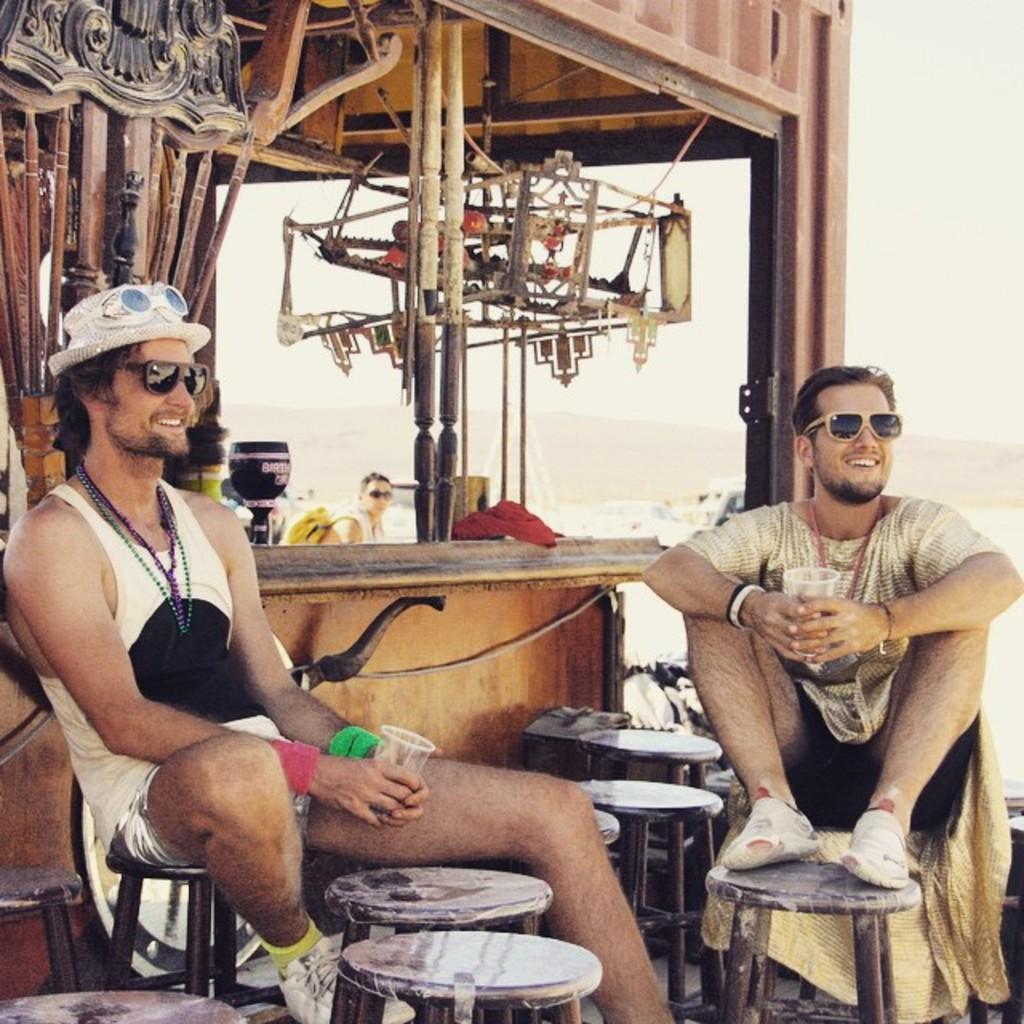Can you describe this image briefly? In the image we can see two persons were sitting and they were smiling. And in front bottom we can see few stools. And coming to the background we can see one person sitting and he is wearing backpack. And we can see some tools around them. 